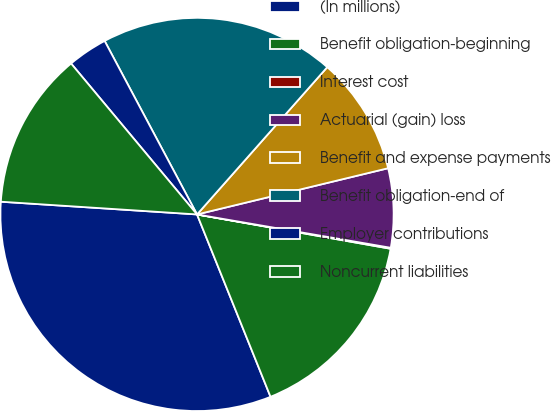<chart> <loc_0><loc_0><loc_500><loc_500><pie_chart><fcel>(In millions)<fcel>Benefit obligation-beginning<fcel>Interest cost<fcel>Actuarial (gain) loss<fcel>Benefit and expense payments<fcel>Benefit obligation-end of<fcel>Employer contributions<fcel>Noncurrent liabilities<nl><fcel>32.13%<fcel>16.11%<fcel>0.08%<fcel>6.49%<fcel>9.7%<fcel>19.31%<fcel>3.28%<fcel>12.9%<nl></chart> 